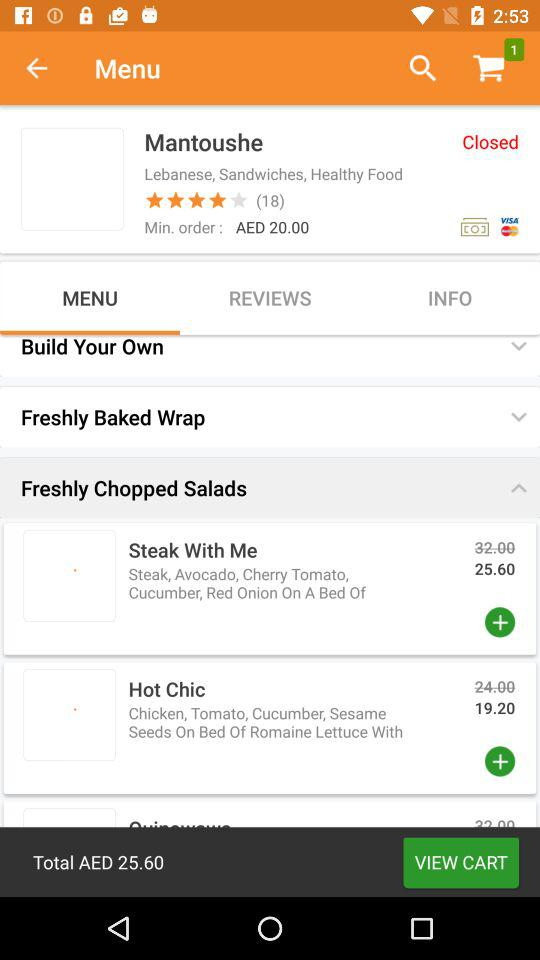Which tab is selected? The selected tab is "MENU". 